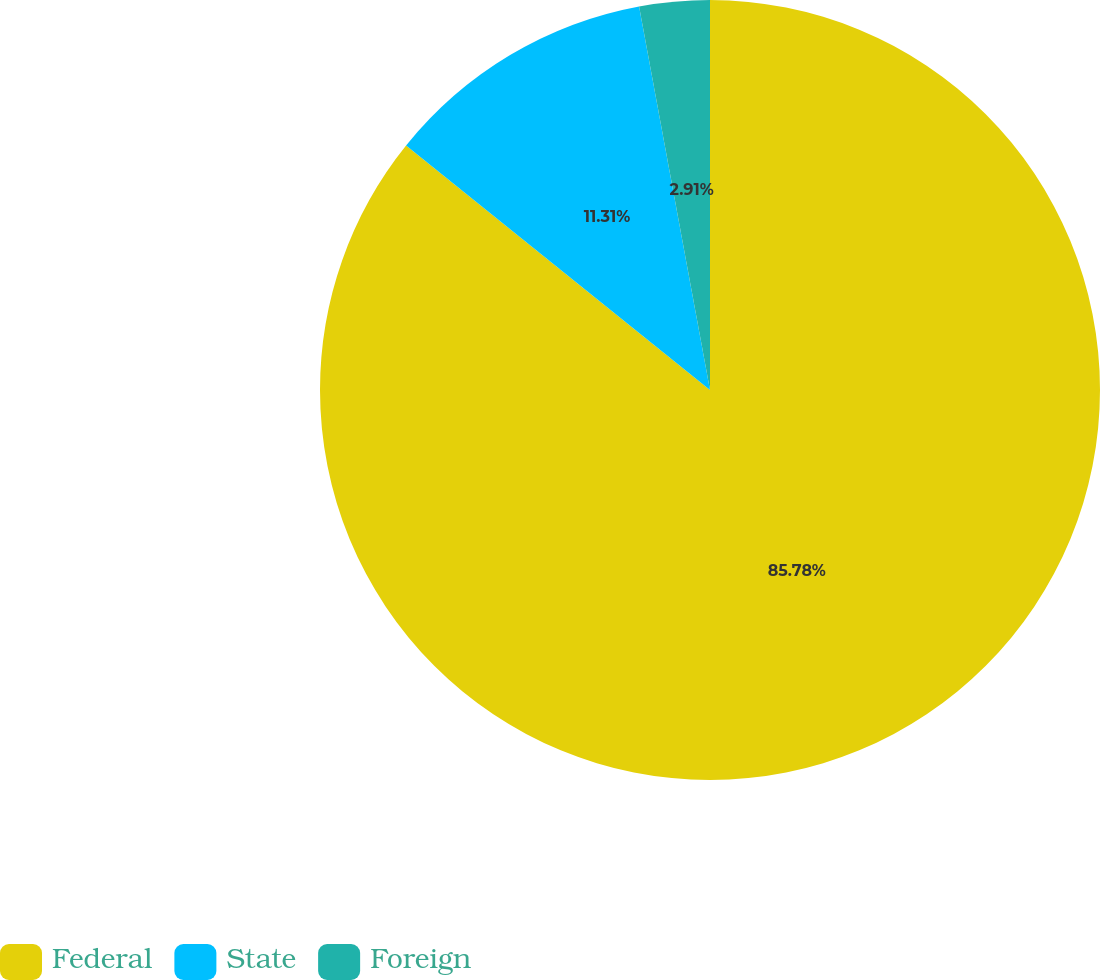<chart> <loc_0><loc_0><loc_500><loc_500><pie_chart><fcel>Federal<fcel>State<fcel>Foreign<nl><fcel>85.78%<fcel>11.31%<fcel>2.91%<nl></chart> 